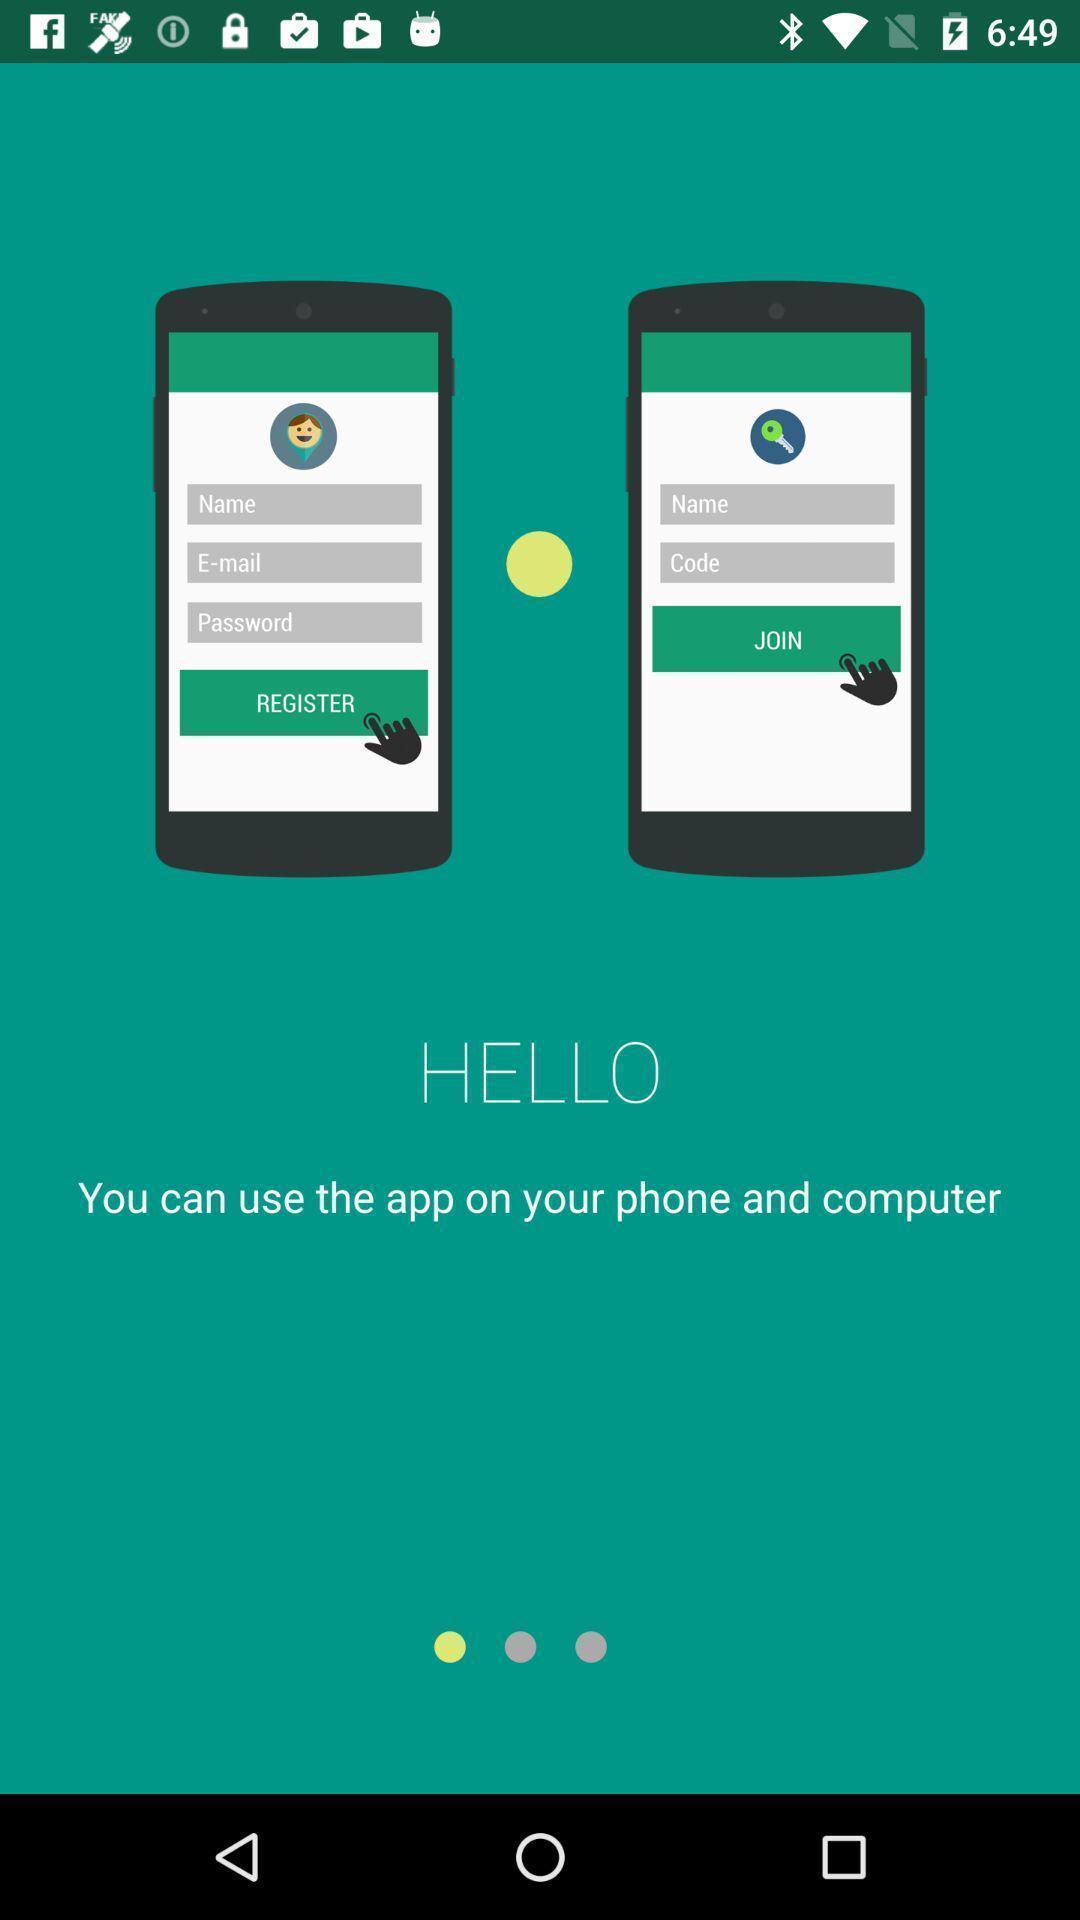Tell me what you see in this picture. Welcome page. 